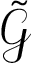Convert formula to latex. <formula><loc_0><loc_0><loc_500><loc_500>\tilde { \mathcal { G } }</formula> 